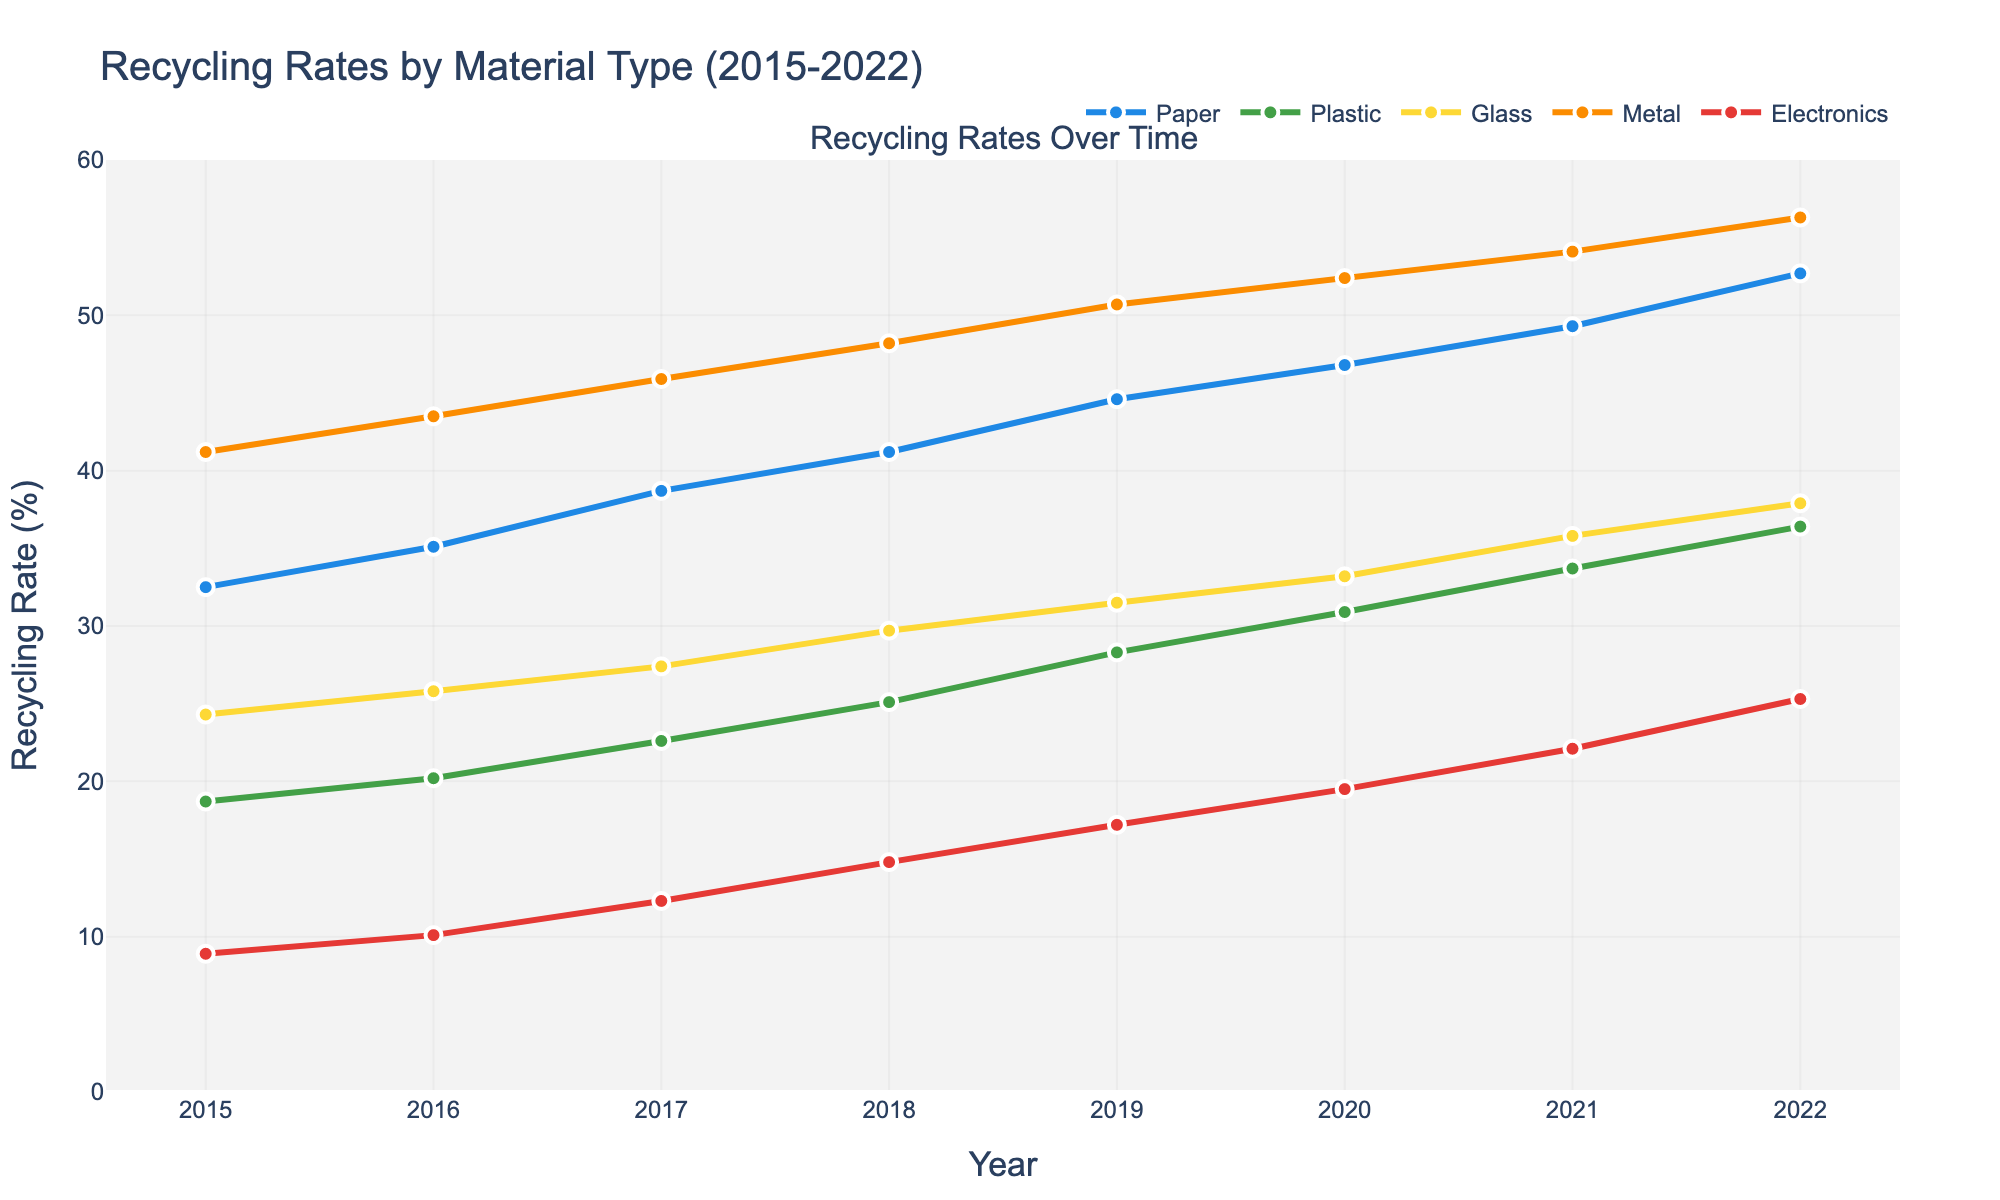What is the overall trend for recycling paper from 2015 to 2022? The line representing paper recycling shows a continual upward trend. Observing the data points for each year, the recycling rate increases consistently from 32.5% in 2015 to 52.7% in 2022.
Answer: Upward trend Which material had the highest recycling rate in 2020? Observe the value for each material in the year 2020 on the y-axis. Metal had the highest recycling rate at 52.4%.
Answer: Metal By how much did the recycling rate of plastics increase from 2015 to 2022? Find the recycling rate of plastics in 2015 (18.7%) and 2022 (36.4%), then subtract the earlier value from the latter: 36.4% - 18.7% = 17.7%.
Answer: 17.7% Which two materials showed nearly parallel growth trends over the given years? Compare the slopes of the lines for each material. Paper and Metal show nearly parallel growth trends with both lines rising steeply and consistently over the years.
Answer: Paper and Metal In which year did the recycling rate of Glass surpass 30%? Look at the line representing Glass and identify the year when the rate first exceeds 30%. This occurs in 2019.
Answer: 2019 What is the average recycling rate for Electronics over this period? Add the recycling rates for Electronics from each year and divide by the number of years: (8.9 + 10.1 + 12.3 + 14.8 + 17.2 + 19.5 + 22.1 + 25.3) / 8 = 16.53%
Answer: 16.53% Which year marks the highest combined recycling rate for all materials? Sum the recycling rates for each material in each year and find the year with the highest total. In 2022, the sum (52.7 + 36.4 + 37.9 + 56.3 + 25.3) = 208.6% is the highest compared to other years.
Answer: 2022 Compare the growth rates of Paper and Electronics from 2015 to 2022. Which grew faster? Calculate the growth for both from 2015 to 2022: Paper (52.7 - 32.5 = 20.2%), Electronics (25.3 - 8.9 = 16.4%). Paper shows a higher growth rate.
Answer: Paper What is the difference in the recycling rate of Metal between 2015 and 2020? Subtract Metal's recycling rate in 2015 (41.2%) from its rate in 2020 (52.4%): 52.4 - 41.2 = 11.2%.
Answer: 11.2% Which material had the least improvement in its recycling rate over the years? Compare the rate of change for each material between 2015 and 2022. Electronics grew by 16.4%, the least compared to others.
Answer: Electronics 